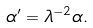<formula> <loc_0><loc_0><loc_500><loc_500>\alpha ^ { \prime } = \lambda ^ { - 2 } \alpha .</formula> 